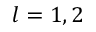<formula> <loc_0><loc_0><loc_500><loc_500>l = 1 , 2</formula> 